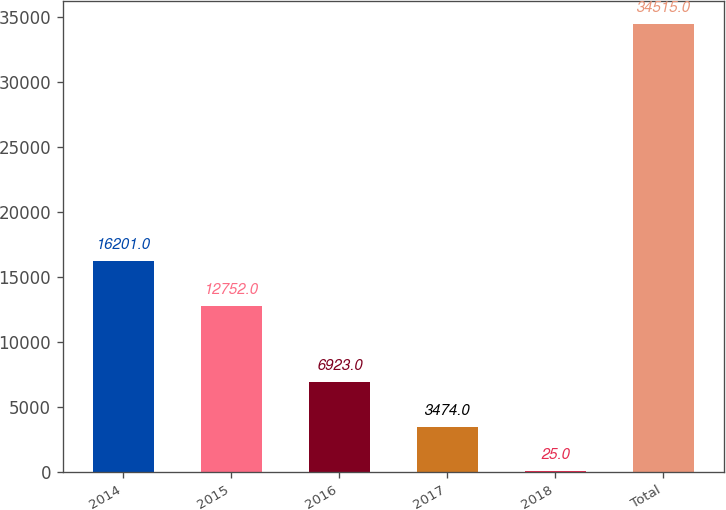Convert chart to OTSL. <chart><loc_0><loc_0><loc_500><loc_500><bar_chart><fcel>2014<fcel>2015<fcel>2016<fcel>2017<fcel>2018<fcel>Total<nl><fcel>16201<fcel>12752<fcel>6923<fcel>3474<fcel>25<fcel>34515<nl></chart> 